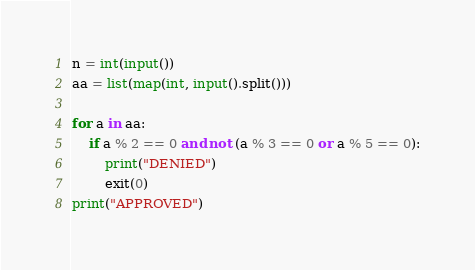Convert code to text. <code><loc_0><loc_0><loc_500><loc_500><_Python_>n = int(input())
aa = list(map(int, input().split()))

for a in aa:
    if a % 2 == 0 and not (a % 3 == 0 or a % 5 == 0):
        print("DENIED")
        exit(0)
print("APPROVED")</code> 